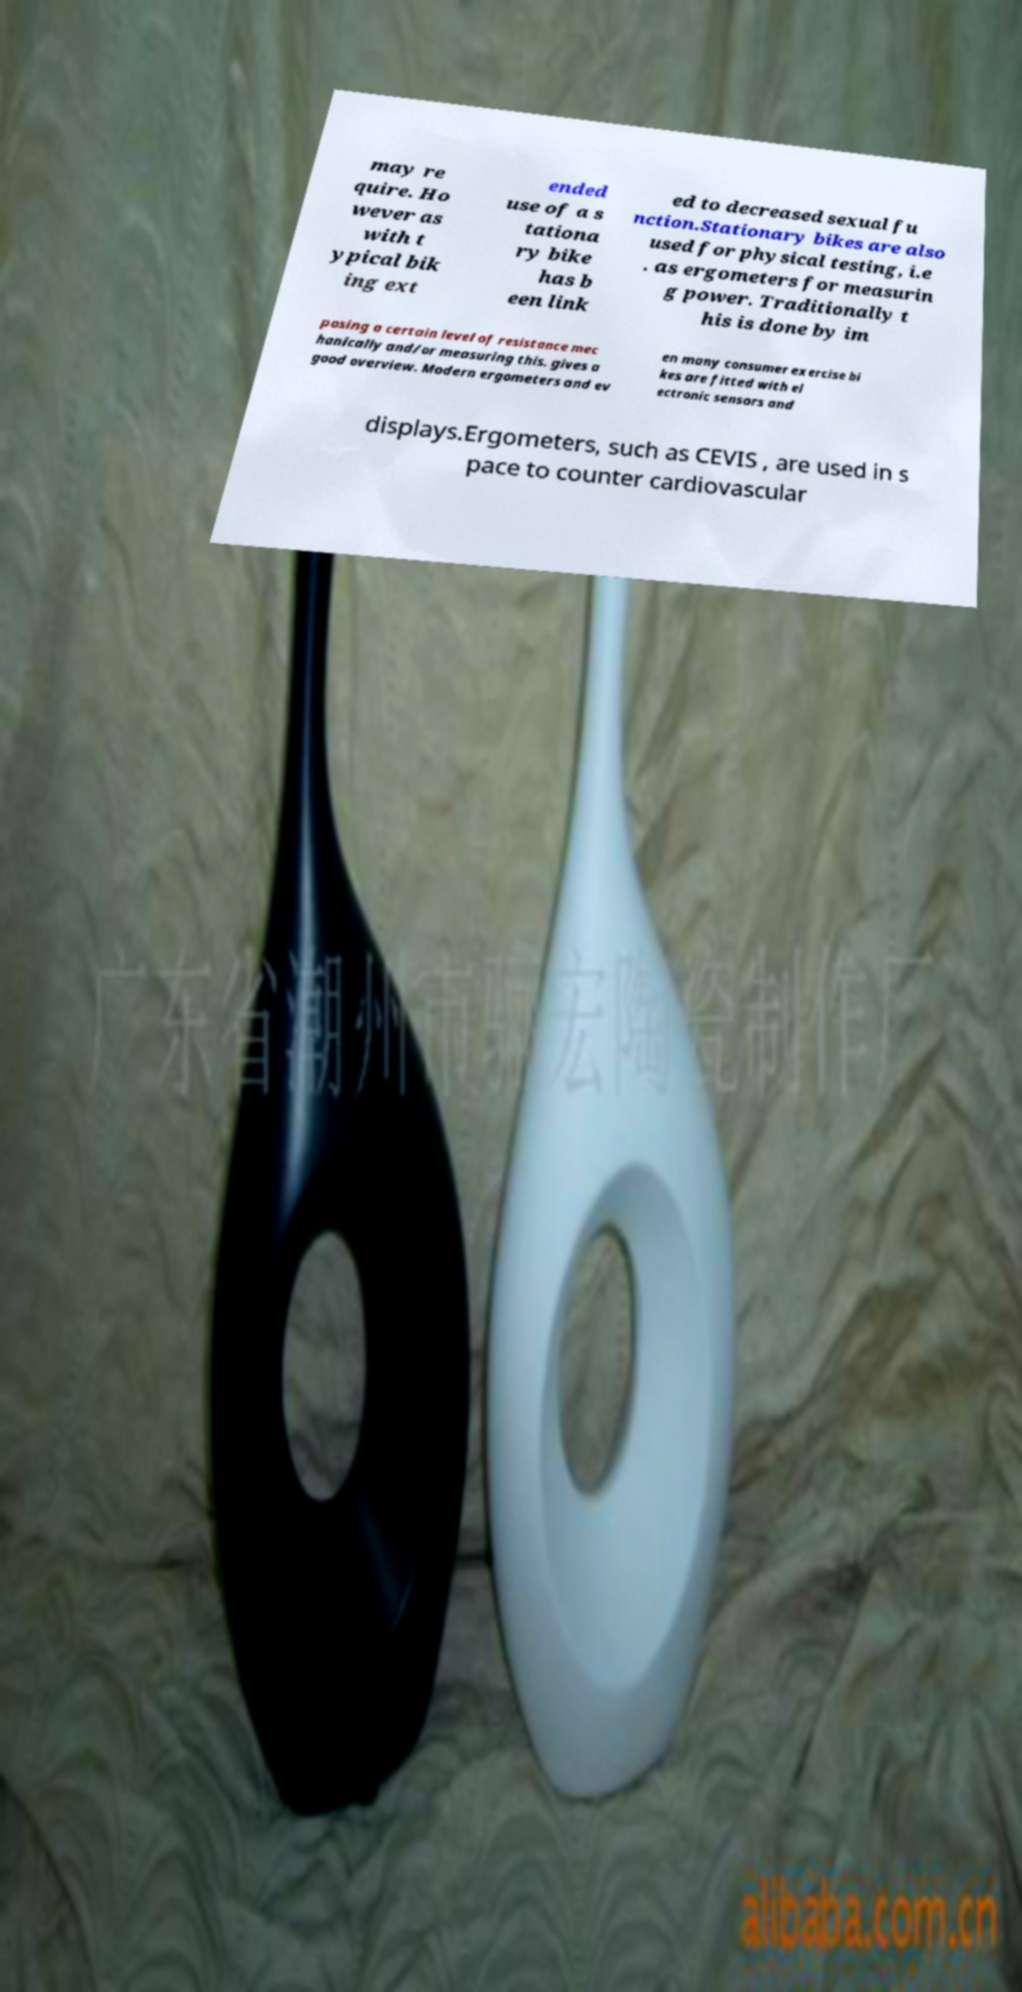What messages or text are displayed in this image? I need them in a readable, typed format. may re quire. Ho wever as with t ypical bik ing ext ended use of a s tationa ry bike has b een link ed to decreased sexual fu nction.Stationary bikes are also used for physical testing, i.e . as ergometers for measurin g power. Traditionally t his is done by im posing a certain level of resistance mec hanically and/or measuring this. gives a good overview. Modern ergometers and ev en many consumer exercise bi kes are fitted with el ectronic sensors and displays.Ergometers, such as CEVIS , are used in s pace to counter cardiovascular 